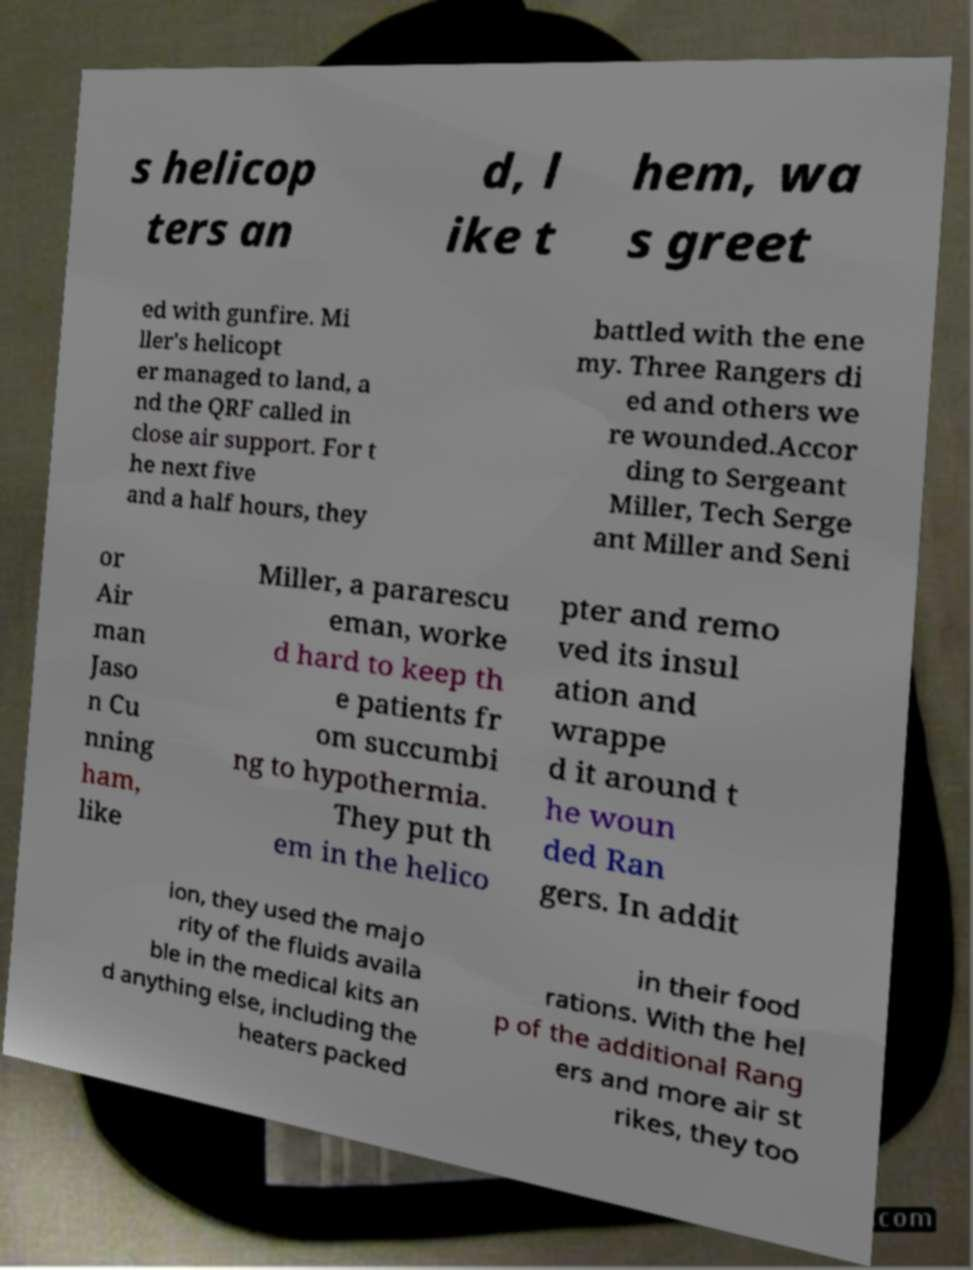For documentation purposes, I need the text within this image transcribed. Could you provide that? s helicop ters an d, l ike t hem, wa s greet ed with gunfire. Mi ller's helicopt er managed to land, a nd the QRF called in close air support. For t he next five and a half hours, they battled with the ene my. Three Rangers di ed and others we re wounded.Accor ding to Sergeant Miller, Tech Serge ant Miller and Seni or Air man Jaso n Cu nning ham, like Miller, a pararescu eman, worke d hard to keep th e patients fr om succumbi ng to hypothermia. They put th em in the helico pter and remo ved its insul ation and wrappe d it around t he woun ded Ran gers. In addit ion, they used the majo rity of the fluids availa ble in the medical kits an d anything else, including the heaters packed in their food rations. With the hel p of the additional Rang ers and more air st rikes, they too 